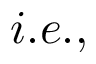<formula> <loc_0><loc_0><loc_500><loc_500>i . e . ,</formula> 